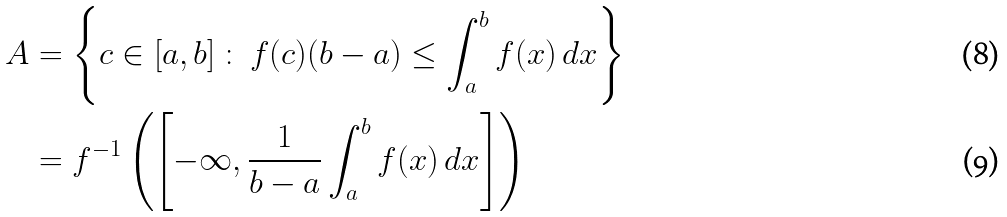Convert formula to latex. <formula><loc_0><loc_0><loc_500><loc_500>A & = \left \{ c \in [ a , b ] \, \colon \, f ( c ) ( b - a ) \leq \int _ { a } ^ { b } { f ( x ) \, d x } \right \} \\ & = f ^ { - 1 } \left ( \left [ - \infty , \frac { 1 } { b - a } \int _ { a } ^ { b } { f ( x ) \, d x } \right ] \right )</formula> 